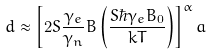Convert formula to latex. <formula><loc_0><loc_0><loc_500><loc_500>d \approx \left [ 2 S \frac { \gamma _ { e } } { \gamma _ { n } } B \left ( \frac { S \hbar { \gamma } _ { e } B _ { 0 } } { k T } \right ) \right ] ^ { \alpha } a</formula> 